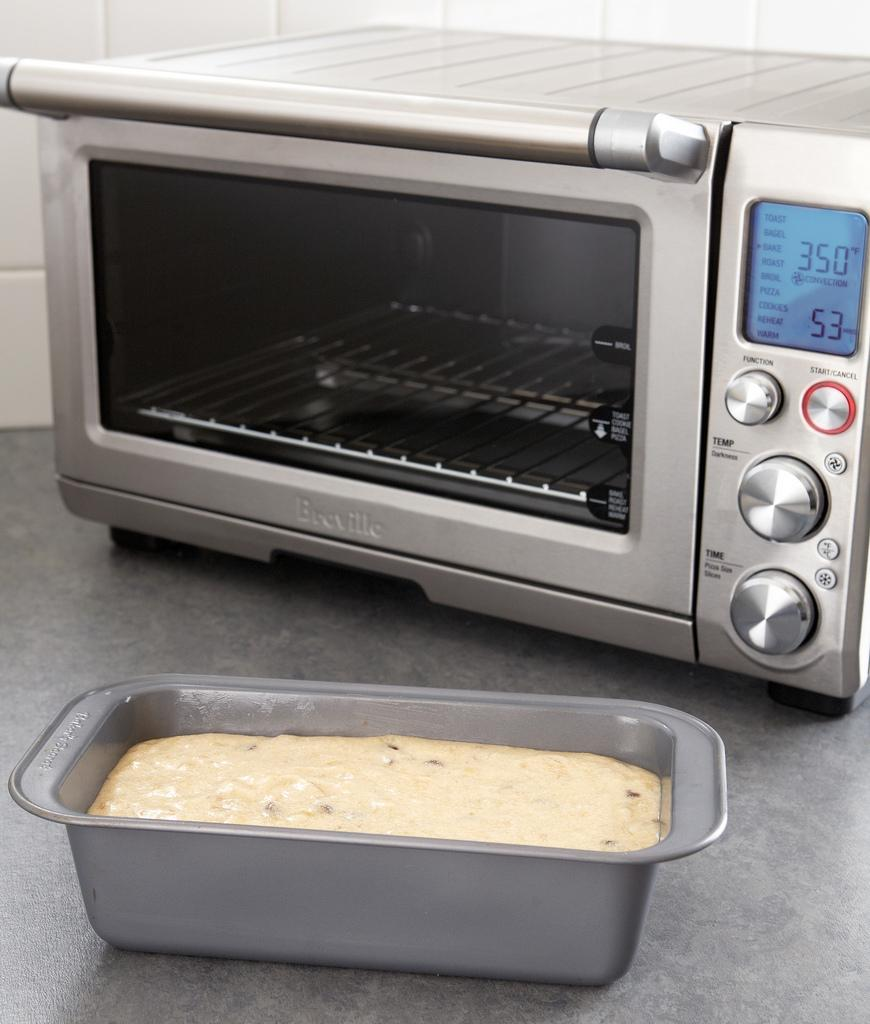<image>
Present a compact description of the photo's key features. A silver toaster oven set at 350 sits on a gray counter top. 